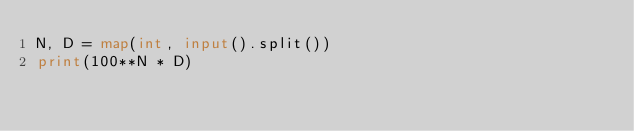<code> <loc_0><loc_0><loc_500><loc_500><_Python_>N, D = map(int, input().split())
print(100**N * D)</code> 